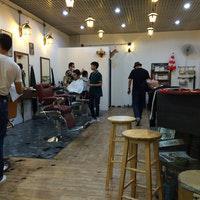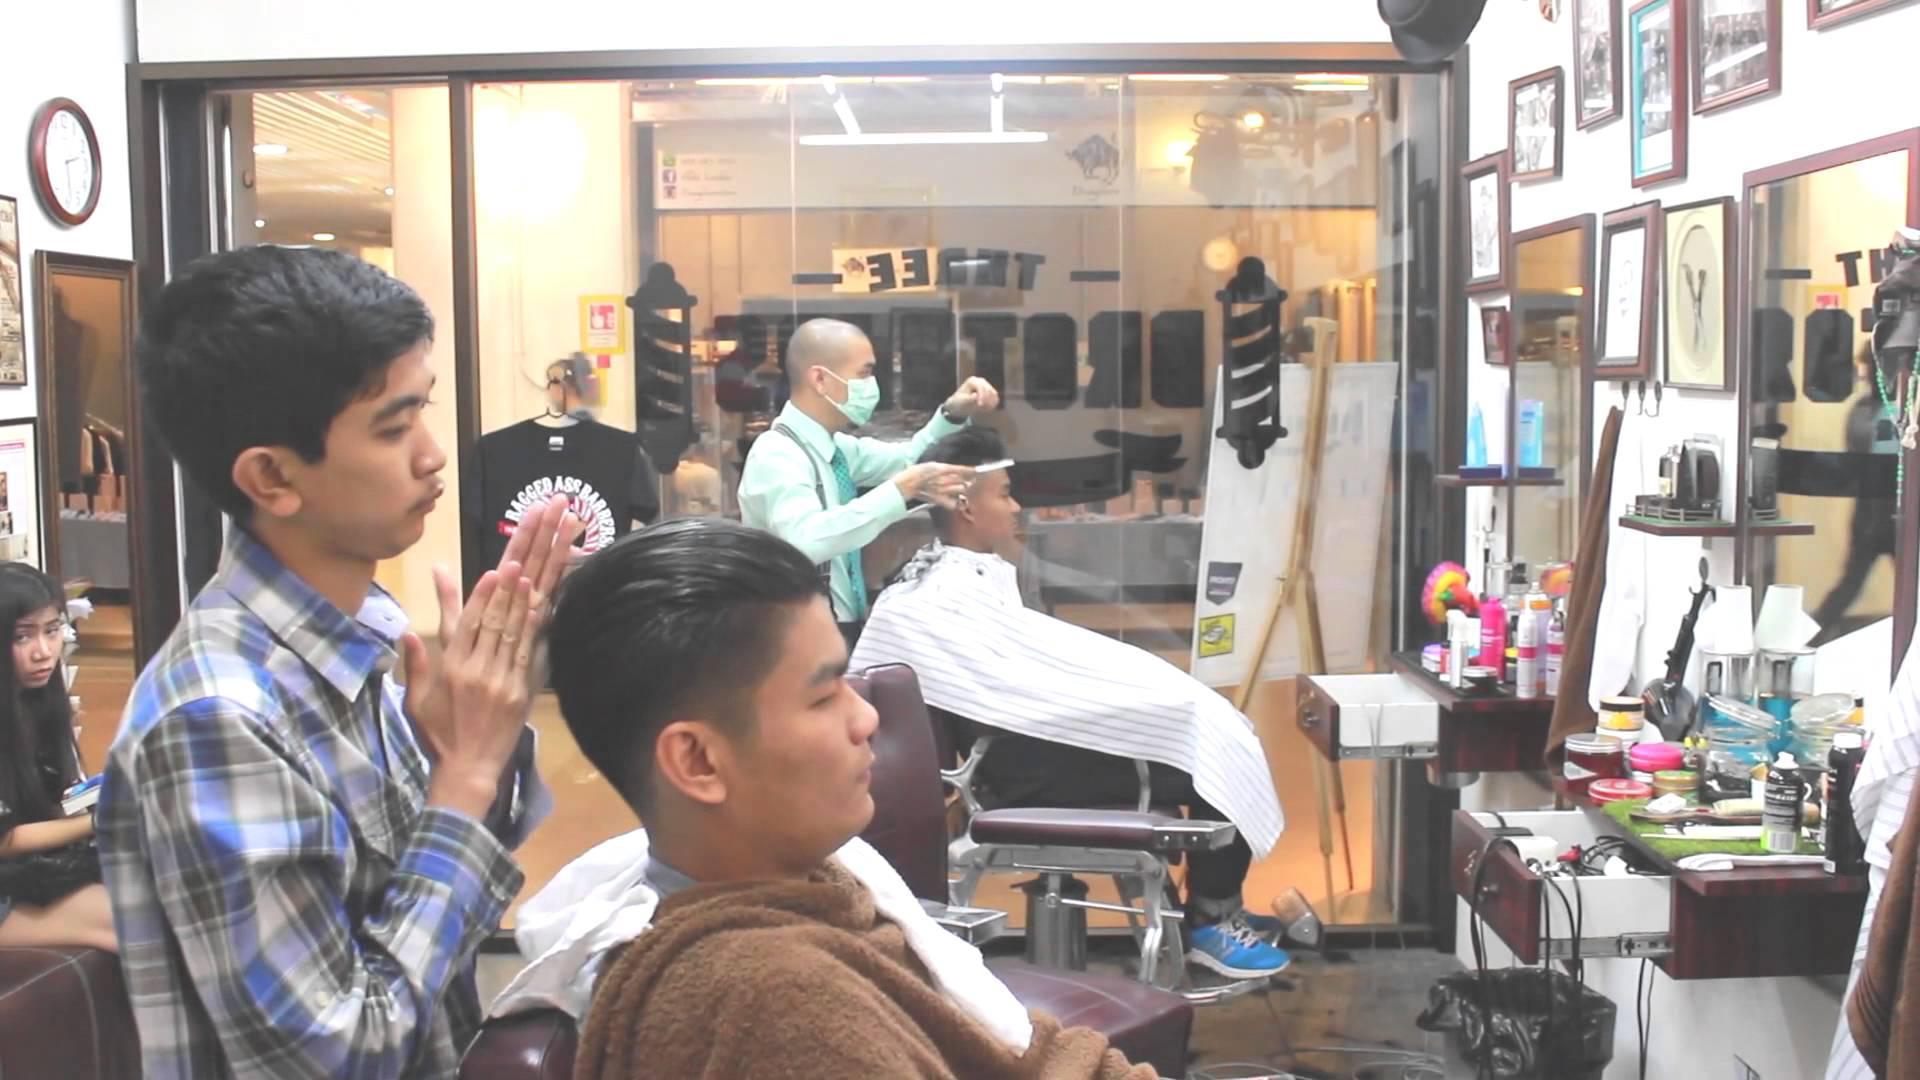The first image is the image on the left, the second image is the image on the right. Examine the images to the left and right. Is the description "Everyone is posed for the photo, nobody is going about their business." accurate? Answer yes or no. No. The first image is the image on the left, the second image is the image on the right. Given the left and right images, does the statement "One image shows three forward-facing men, and the man in the middle has a mustache and wears a vest." hold true? Answer yes or no. No. 